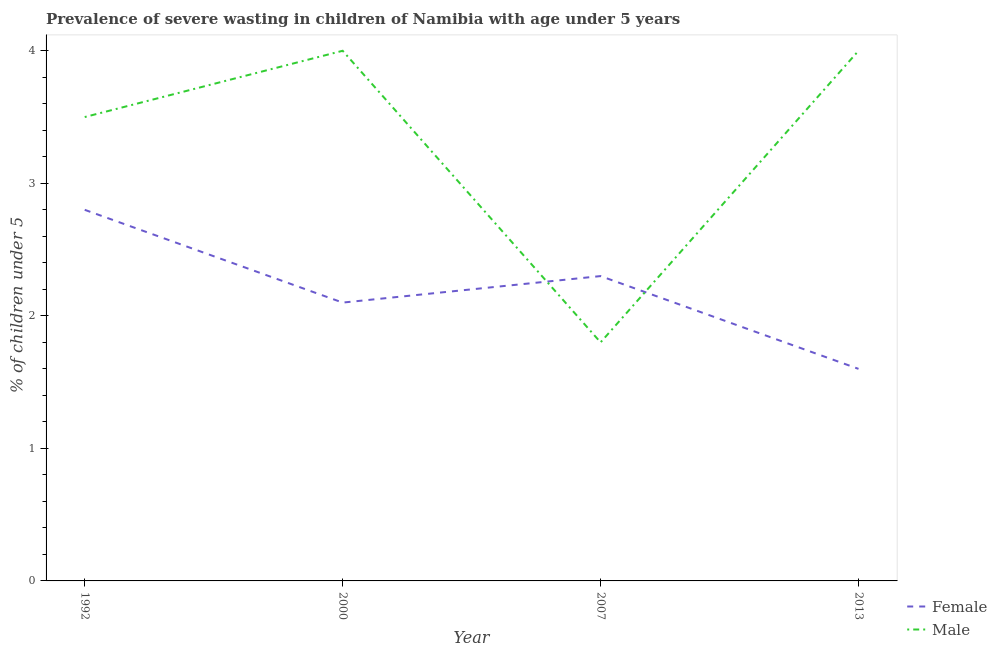Is the number of lines equal to the number of legend labels?
Your answer should be compact. Yes. What is the percentage of undernourished male children in 2007?
Make the answer very short. 1.8. Across all years, what is the maximum percentage of undernourished male children?
Keep it short and to the point. 4. Across all years, what is the minimum percentage of undernourished female children?
Keep it short and to the point. 1.6. In which year was the percentage of undernourished male children maximum?
Keep it short and to the point. 2000. What is the total percentage of undernourished female children in the graph?
Make the answer very short. 8.8. What is the difference between the percentage of undernourished female children in 1992 and that in 2013?
Offer a very short reply. 1.2. What is the difference between the percentage of undernourished female children in 2007 and the percentage of undernourished male children in 2000?
Offer a very short reply. -1.7. What is the average percentage of undernourished male children per year?
Provide a short and direct response. 3.32. In the year 2000, what is the difference between the percentage of undernourished male children and percentage of undernourished female children?
Provide a succinct answer. 1.9. In how many years, is the percentage of undernourished female children greater than 0.4 %?
Keep it short and to the point. 4. Is the difference between the percentage of undernourished male children in 1992 and 2007 greater than the difference between the percentage of undernourished female children in 1992 and 2007?
Offer a terse response. Yes. What is the difference between the highest and the lowest percentage of undernourished female children?
Offer a terse response. 1.2. In how many years, is the percentage of undernourished female children greater than the average percentage of undernourished female children taken over all years?
Your response must be concise. 2. Is the percentage of undernourished female children strictly greater than the percentage of undernourished male children over the years?
Keep it short and to the point. No. Does the graph contain grids?
Provide a short and direct response. No. What is the title of the graph?
Your response must be concise. Prevalence of severe wasting in children of Namibia with age under 5 years. What is the label or title of the Y-axis?
Provide a short and direct response.  % of children under 5. What is the  % of children under 5 of Female in 1992?
Provide a succinct answer. 2.8. What is the  % of children under 5 in Male in 1992?
Give a very brief answer. 3.5. What is the  % of children under 5 of Female in 2000?
Make the answer very short. 2.1. What is the  % of children under 5 of Male in 2000?
Your answer should be compact. 4. What is the  % of children under 5 in Female in 2007?
Offer a very short reply. 2.3. What is the  % of children under 5 in Male in 2007?
Offer a very short reply. 1.8. What is the  % of children under 5 of Female in 2013?
Keep it short and to the point. 1.6. What is the  % of children under 5 in Male in 2013?
Your answer should be very brief. 4. Across all years, what is the maximum  % of children under 5 of Female?
Your answer should be very brief. 2.8. Across all years, what is the minimum  % of children under 5 in Female?
Provide a succinct answer. 1.6. Across all years, what is the minimum  % of children under 5 in Male?
Provide a short and direct response. 1.8. What is the total  % of children under 5 of Male in the graph?
Make the answer very short. 13.3. What is the difference between the  % of children under 5 of Male in 1992 and that in 2007?
Your answer should be very brief. 1.7. What is the difference between the  % of children under 5 of Male in 1992 and that in 2013?
Give a very brief answer. -0.5. What is the difference between the  % of children under 5 of Female in 2000 and that in 2007?
Ensure brevity in your answer.  -0.2. What is the difference between the  % of children under 5 in Male in 2000 and that in 2007?
Keep it short and to the point. 2.2. What is the difference between the  % of children under 5 in Female in 2000 and that in 2013?
Your answer should be compact. 0.5. What is the difference between the  % of children under 5 of Male in 2000 and that in 2013?
Your response must be concise. 0. What is the difference between the  % of children under 5 of Male in 2007 and that in 2013?
Provide a short and direct response. -2.2. What is the difference between the  % of children under 5 in Female in 1992 and the  % of children under 5 in Male in 2000?
Keep it short and to the point. -1.2. What is the difference between the  % of children under 5 of Female in 1992 and the  % of children under 5 of Male in 2007?
Make the answer very short. 1. What is the difference between the  % of children under 5 in Female in 2000 and the  % of children under 5 in Male in 2007?
Offer a terse response. 0.3. What is the difference between the  % of children under 5 in Female in 2007 and the  % of children under 5 in Male in 2013?
Provide a succinct answer. -1.7. What is the average  % of children under 5 in Male per year?
Provide a succinct answer. 3.33. In the year 2000, what is the difference between the  % of children under 5 in Female and  % of children under 5 in Male?
Provide a succinct answer. -1.9. In the year 2007, what is the difference between the  % of children under 5 of Female and  % of children under 5 of Male?
Offer a very short reply. 0.5. What is the ratio of the  % of children under 5 of Female in 1992 to that in 2000?
Your answer should be very brief. 1.33. What is the ratio of the  % of children under 5 of Male in 1992 to that in 2000?
Offer a terse response. 0.88. What is the ratio of the  % of children under 5 of Female in 1992 to that in 2007?
Your answer should be very brief. 1.22. What is the ratio of the  % of children under 5 in Male in 1992 to that in 2007?
Provide a succinct answer. 1.94. What is the ratio of the  % of children under 5 in Female in 2000 to that in 2007?
Make the answer very short. 0.91. What is the ratio of the  % of children under 5 of Male in 2000 to that in 2007?
Give a very brief answer. 2.22. What is the ratio of the  % of children under 5 of Female in 2000 to that in 2013?
Your response must be concise. 1.31. What is the ratio of the  % of children under 5 of Male in 2000 to that in 2013?
Provide a succinct answer. 1. What is the ratio of the  % of children under 5 of Female in 2007 to that in 2013?
Your response must be concise. 1.44. What is the ratio of the  % of children under 5 in Male in 2007 to that in 2013?
Keep it short and to the point. 0.45. What is the difference between the highest and the second highest  % of children under 5 of Female?
Your answer should be compact. 0.5. What is the difference between the highest and the lowest  % of children under 5 of Male?
Give a very brief answer. 2.2. 